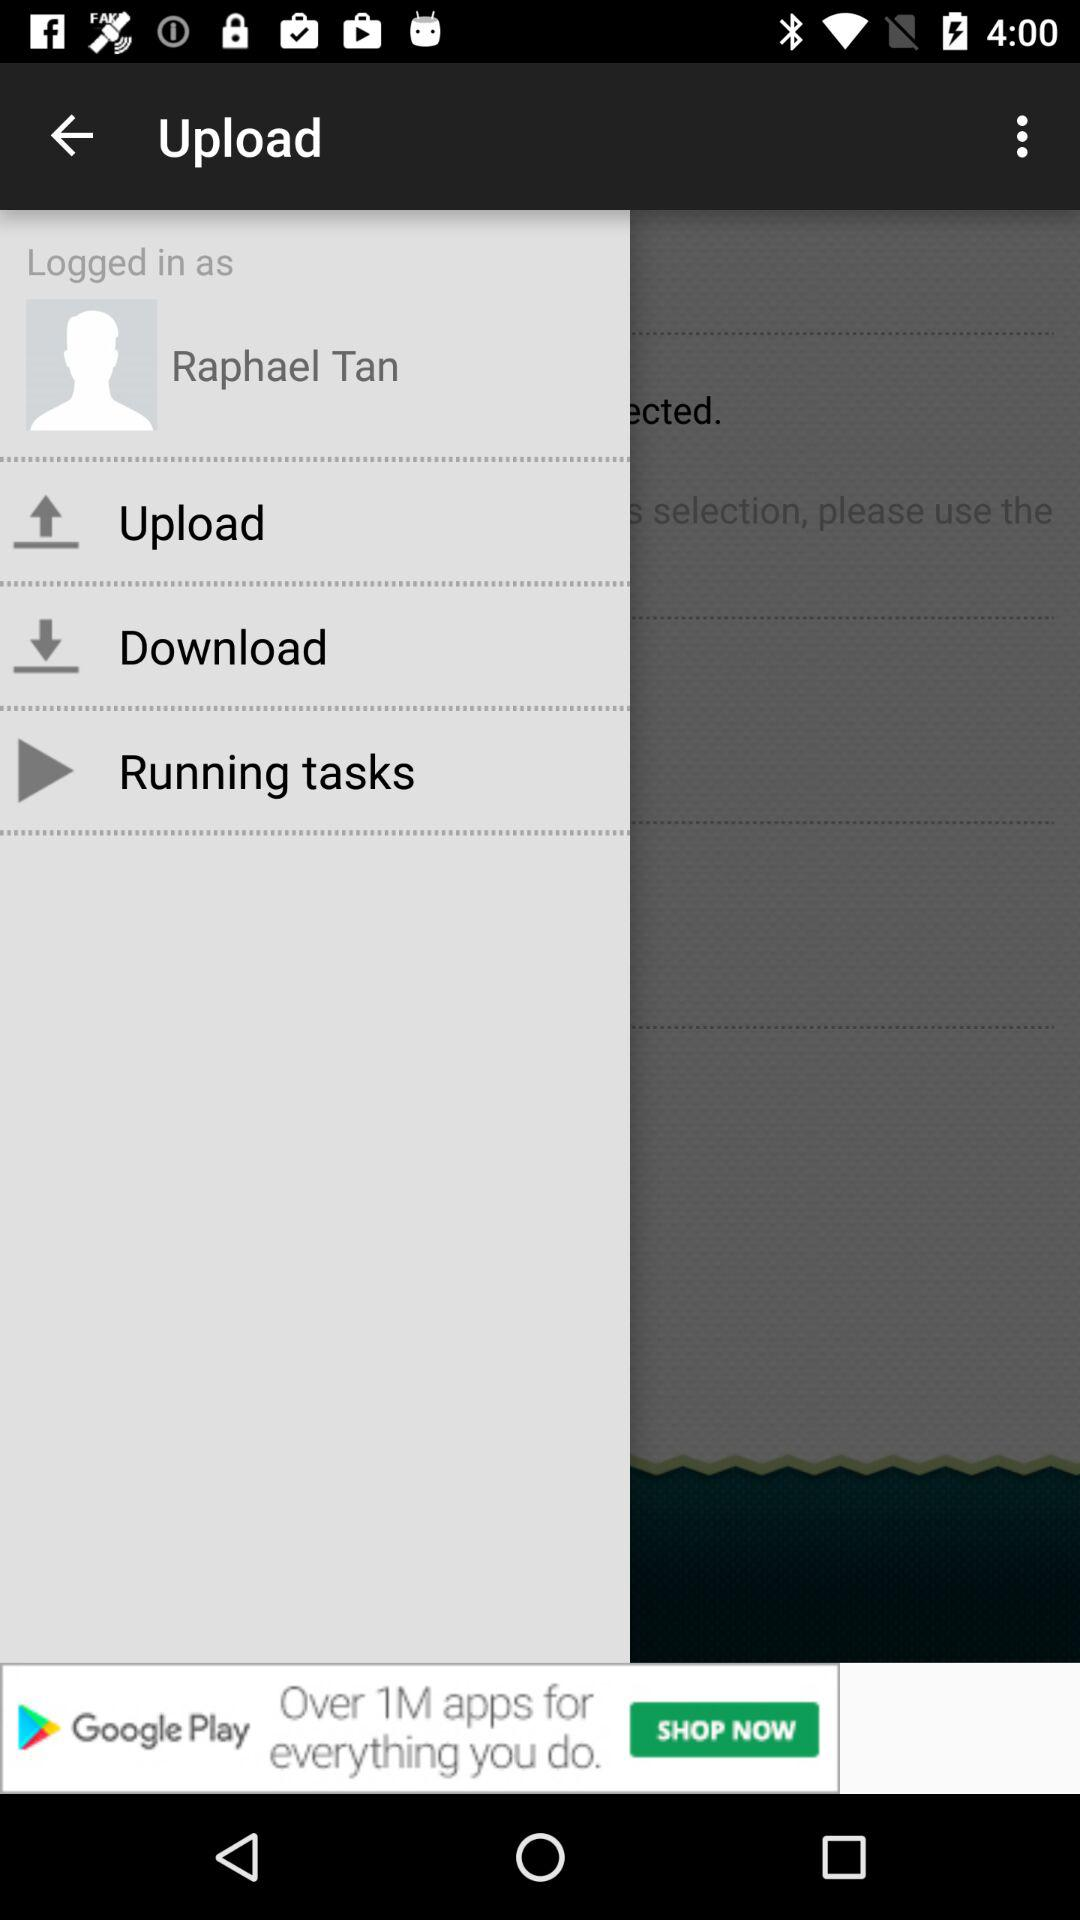What is the user name? The user name is Raphael Tan. 